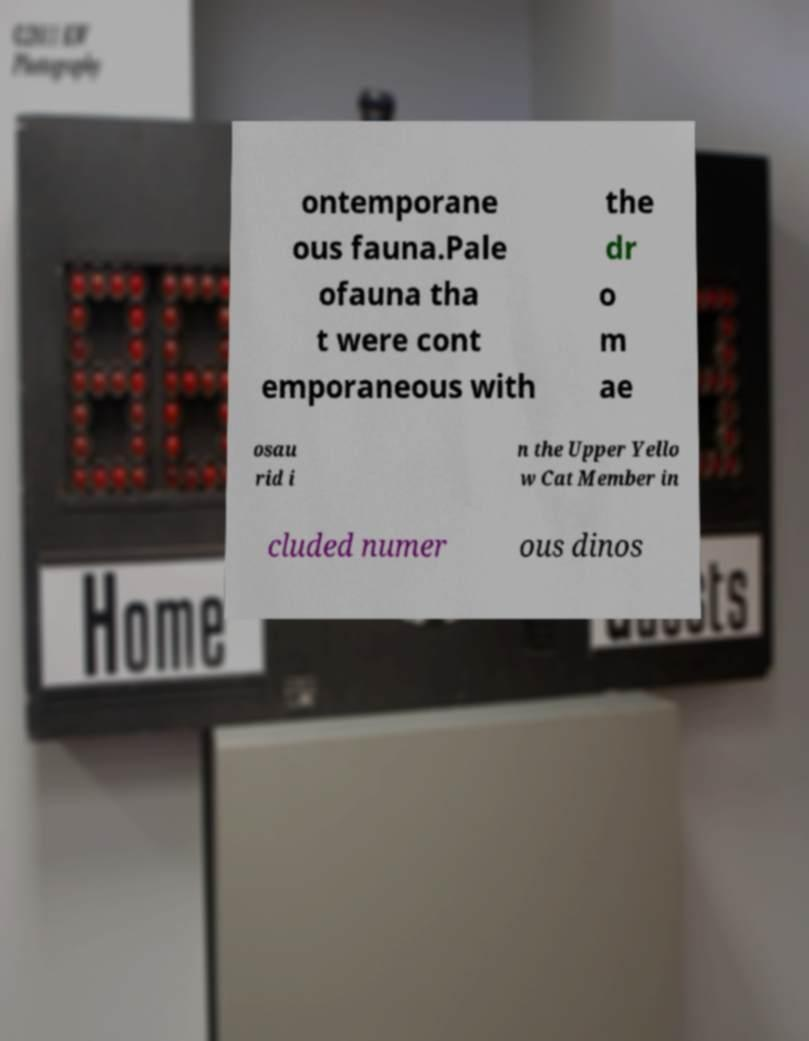Please read and relay the text visible in this image. What does it say? ontemporane ous fauna.Pale ofauna tha t were cont emporaneous with the dr o m ae osau rid i n the Upper Yello w Cat Member in cluded numer ous dinos 